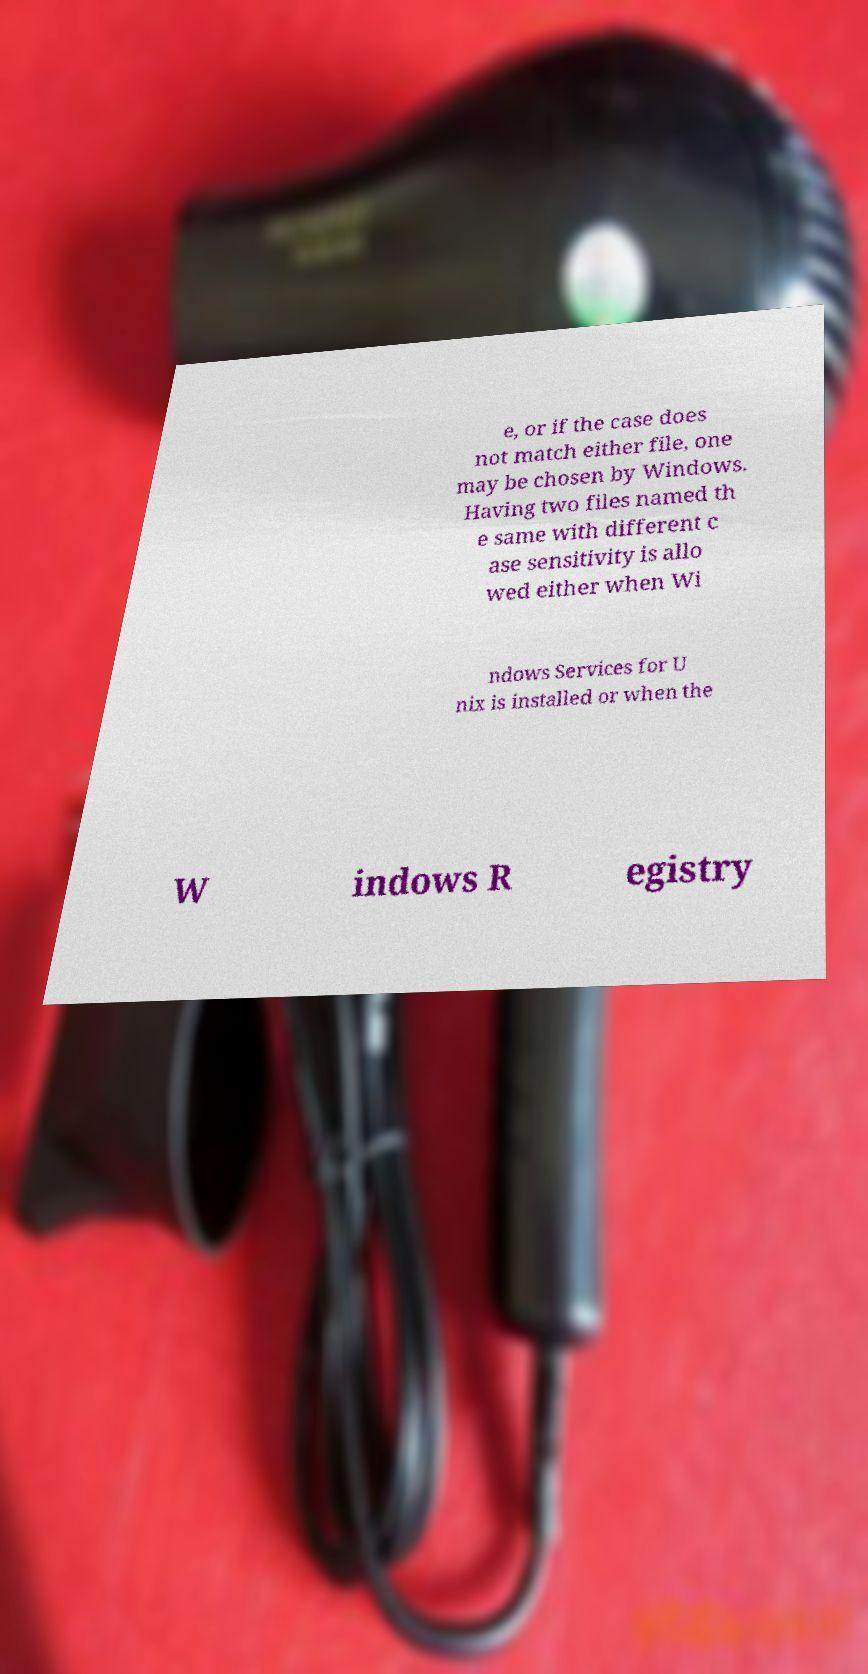Please read and relay the text visible in this image. What does it say? e, or if the case does not match either file, one may be chosen by Windows. Having two files named th e same with different c ase sensitivity is allo wed either when Wi ndows Services for U nix is installed or when the W indows R egistry 